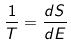Convert formula to latex. <formula><loc_0><loc_0><loc_500><loc_500>\frac { 1 } { T } = \frac { d S } { d E }</formula> 